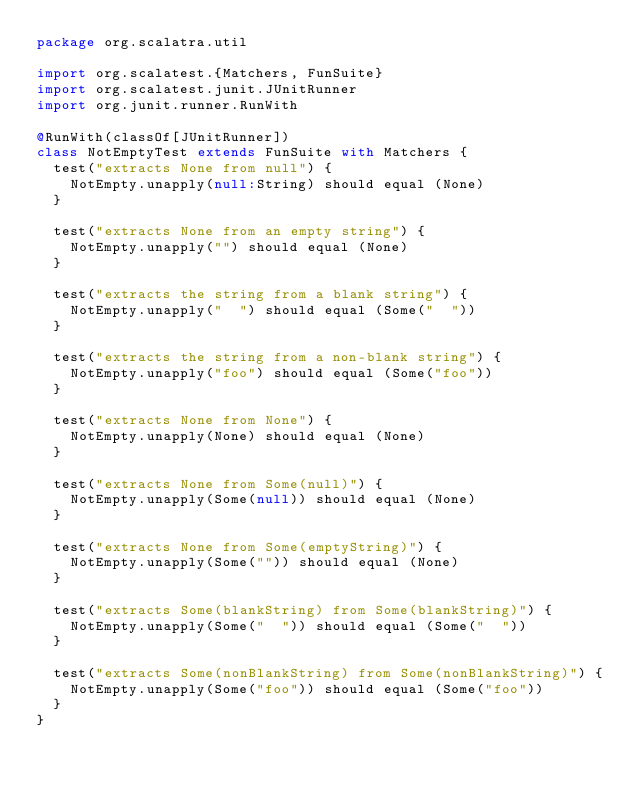<code> <loc_0><loc_0><loc_500><loc_500><_Scala_>package org.scalatra.util

import org.scalatest.{Matchers, FunSuite}
import org.scalatest.junit.JUnitRunner
import org.junit.runner.RunWith

@RunWith(classOf[JUnitRunner])
class NotEmptyTest extends FunSuite with Matchers {
  test("extracts None from null") {
    NotEmpty.unapply(null:String) should equal (None)
  }

  test("extracts None from an empty string") {
    NotEmpty.unapply("") should equal (None)
  }

  test("extracts the string from a blank string") {
    NotEmpty.unapply("  ") should equal (Some("  "))
  }

  test("extracts the string from a non-blank string") {
    NotEmpty.unapply("foo") should equal (Some("foo"))
  }

  test("extracts None from None") {
    NotEmpty.unapply(None) should equal (None)
  }

  test("extracts None from Some(null)") {
    NotEmpty.unapply(Some(null)) should equal (None)
  }

  test("extracts None from Some(emptyString)") {
    NotEmpty.unapply(Some("")) should equal (None)
  }

  test("extracts Some(blankString) from Some(blankString)") {
    NotEmpty.unapply(Some("  ")) should equal (Some("  "))
  }

  test("extracts Some(nonBlankString) from Some(nonBlankString)") {
    NotEmpty.unapply(Some("foo")) should equal (Some("foo"))
  }
}
</code> 